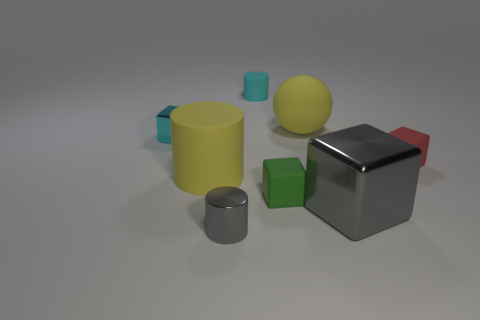What shapes and colors do you observe in the image? The image showcases a variety of geometric shapes including a large yellow cylinder, a large grey cube, large and small red cubes, large and small green cubes, and small cyan cylinders. The colors prominently featured are yellow, grey, red, green, and cyan.  Which object appears to be closest to the center of the composition? The large grey cube is the object that appears to be nearest to the central point of the composition, drawing the viewer's eye as the central focus. 